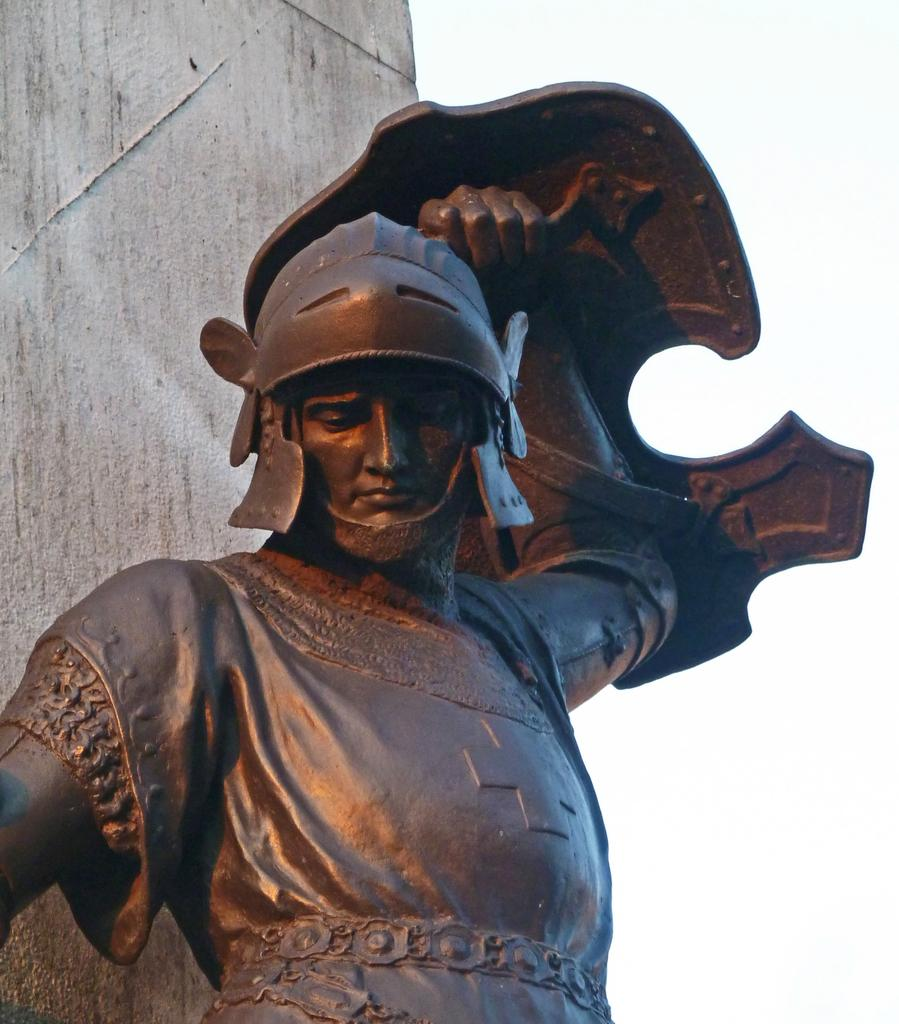What is the main subject in the front of the image? There is a statue in the front of the image. What can be seen in the background of the image? There is a wall in the background of the image. Can you see a lake in the image? There is no lake present in the image; it only features a statue and a wall. 